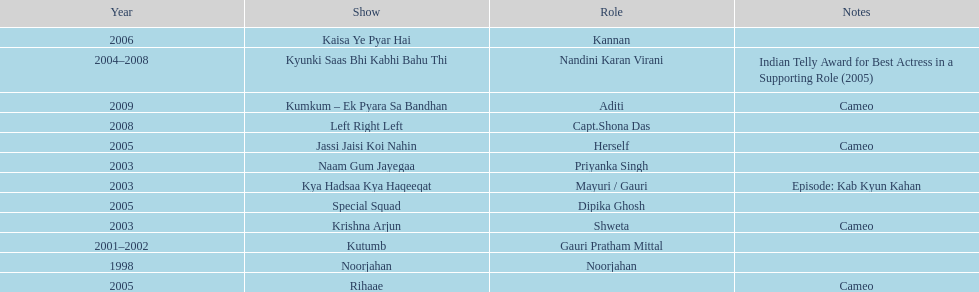Which television show was gauri in for the longest amount of time? Kyunki Saas Bhi Kabhi Bahu Thi. 